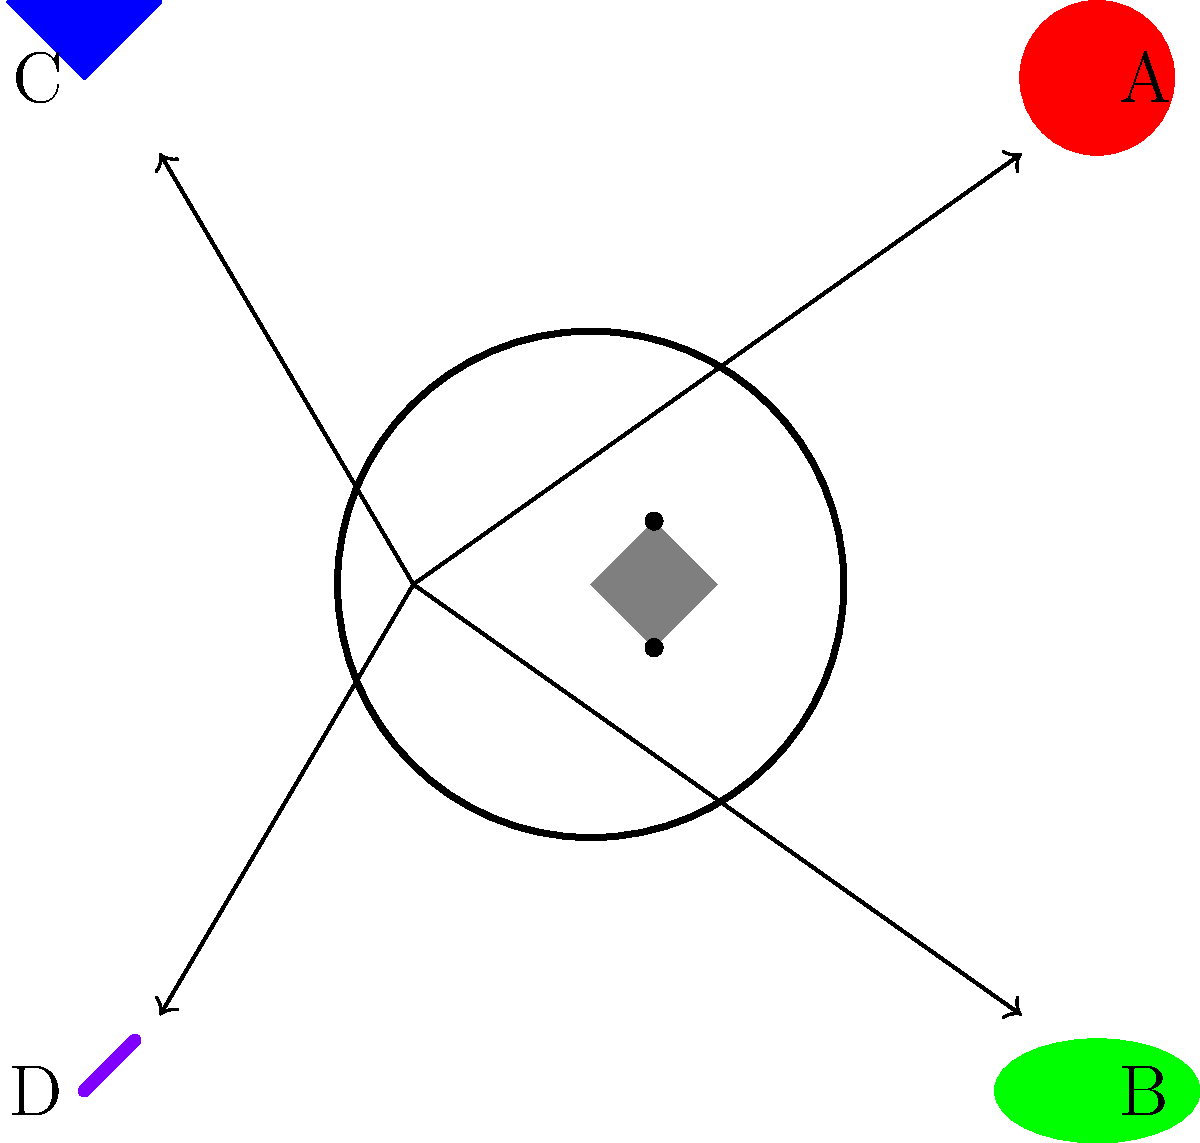Based on the diagram, which cat toy (labeled A, B, C, or D) is most likely to effectively distract the kitten from the knitting basket in the center, considering the toy's distance from the basket and its potential to capture the kitten's attention? To determine which cat toy will best distract the kitten from the knitting basket, we need to consider two main factors:

1. Distance from the basket: Toys closer to the basket are more likely to catch the kitten's attention.
2. Type of toy: Different toys have varying levels of appeal to cats.

Let's analyze each toy:

A. Red ball: Located at $(2,2)$, relatively close to the basket. Balls are generally appealing to cats due to their rolling motion.

B. Green mouse: Located at $(2,-2)$, also close to the basket. Toy mice often appeal to a cat's hunting instincts.

C. Blue feather: Located at $(-2,2)$, farther from the basket. Feathers are typically very enticing for cats due to their movement and texture.

D. Purple laser pointer: Located at $(-2,-2)$, farther from the basket. Laser pointers are usually highly effective at capturing a cat's attention due to their fast-moving, unpredictable light.

Considering these factors:
- A and B are closer to the basket, giving them an advantage.
- C and D are farther but potentially more enticing.

The laser pointer (D) is likely to be the most effective distraction despite its distance. Cats are often irresistibly drawn to the quick, erratic movements of laser pointers, which trigger their hunting instincts. The intense focus required to chase the laser light would likely pull the kitten away from the knitting basket more effectively than the other toys.
Answer: D 